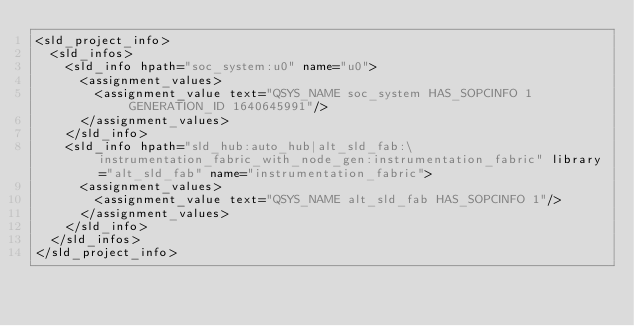<code> <loc_0><loc_0><loc_500><loc_500><_Scheme_><sld_project_info>
  <sld_infos>
    <sld_info hpath="soc_system:u0" name="u0">
      <assignment_values>
        <assignment_value text="QSYS_NAME soc_system HAS_SOPCINFO 1 GENERATION_ID 1640645991"/>
      </assignment_values>
    </sld_info>
    <sld_info hpath="sld_hub:auto_hub|alt_sld_fab:\instrumentation_fabric_with_node_gen:instrumentation_fabric" library="alt_sld_fab" name="instrumentation_fabric">
      <assignment_values>
        <assignment_value text="QSYS_NAME alt_sld_fab HAS_SOPCINFO 1"/>
      </assignment_values>
    </sld_info>
  </sld_infos>
</sld_project_info>
</code> 